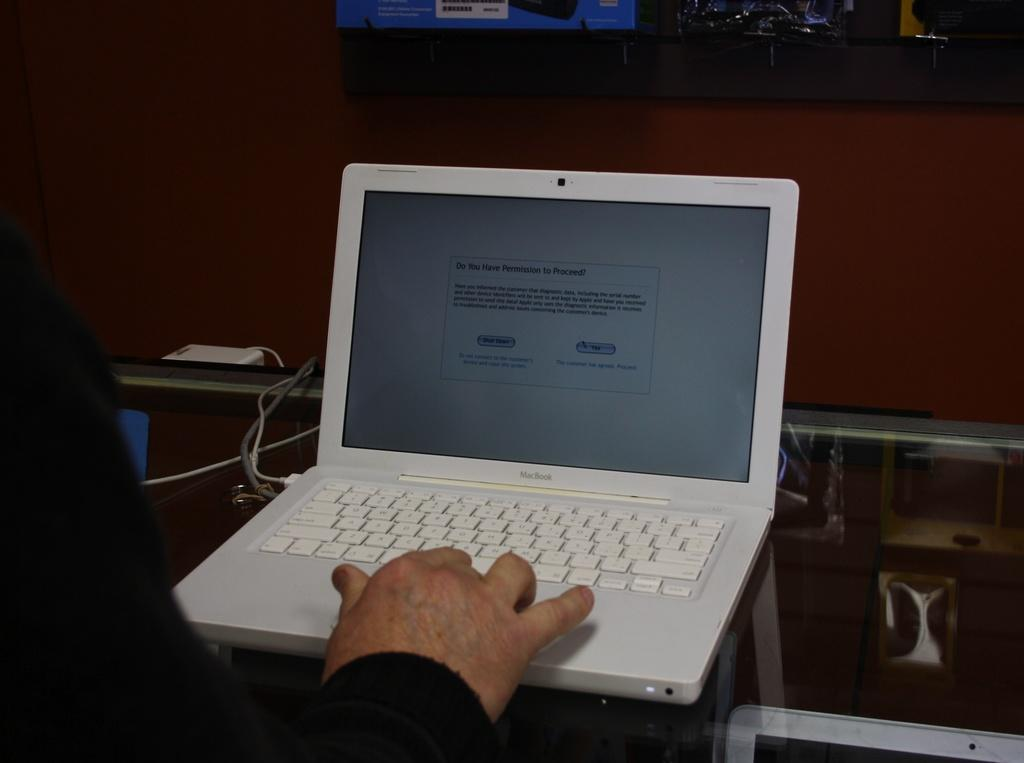<image>
Offer a succinct explanation of the picture presented. a person on a macbook with the screen reading do you have permission to proceed 